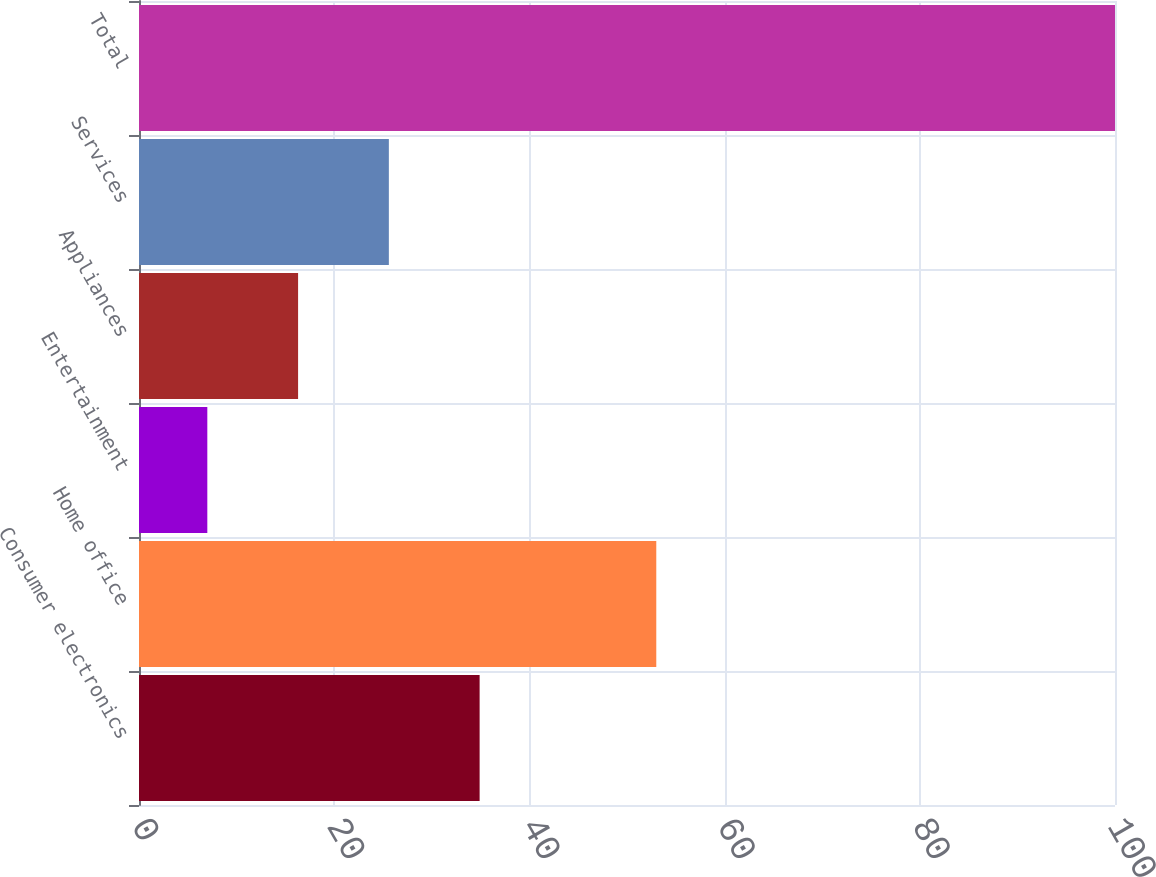Convert chart to OTSL. <chart><loc_0><loc_0><loc_500><loc_500><bar_chart><fcel>Consumer electronics<fcel>Home office<fcel>Entertainment<fcel>Appliances<fcel>Services<fcel>Total<nl><fcel>34.9<fcel>53<fcel>7<fcel>16.3<fcel>25.6<fcel>100<nl></chart> 